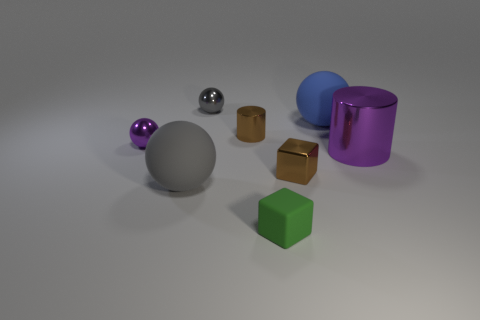Are there any patterns or textures on the objects or the floor? The objects themselves do not display any intricate patterns or textures; they have a smooth finish. The floor has a subtle, speckled texture, which provides a neutral background to highlight the objects' colors and forms. 